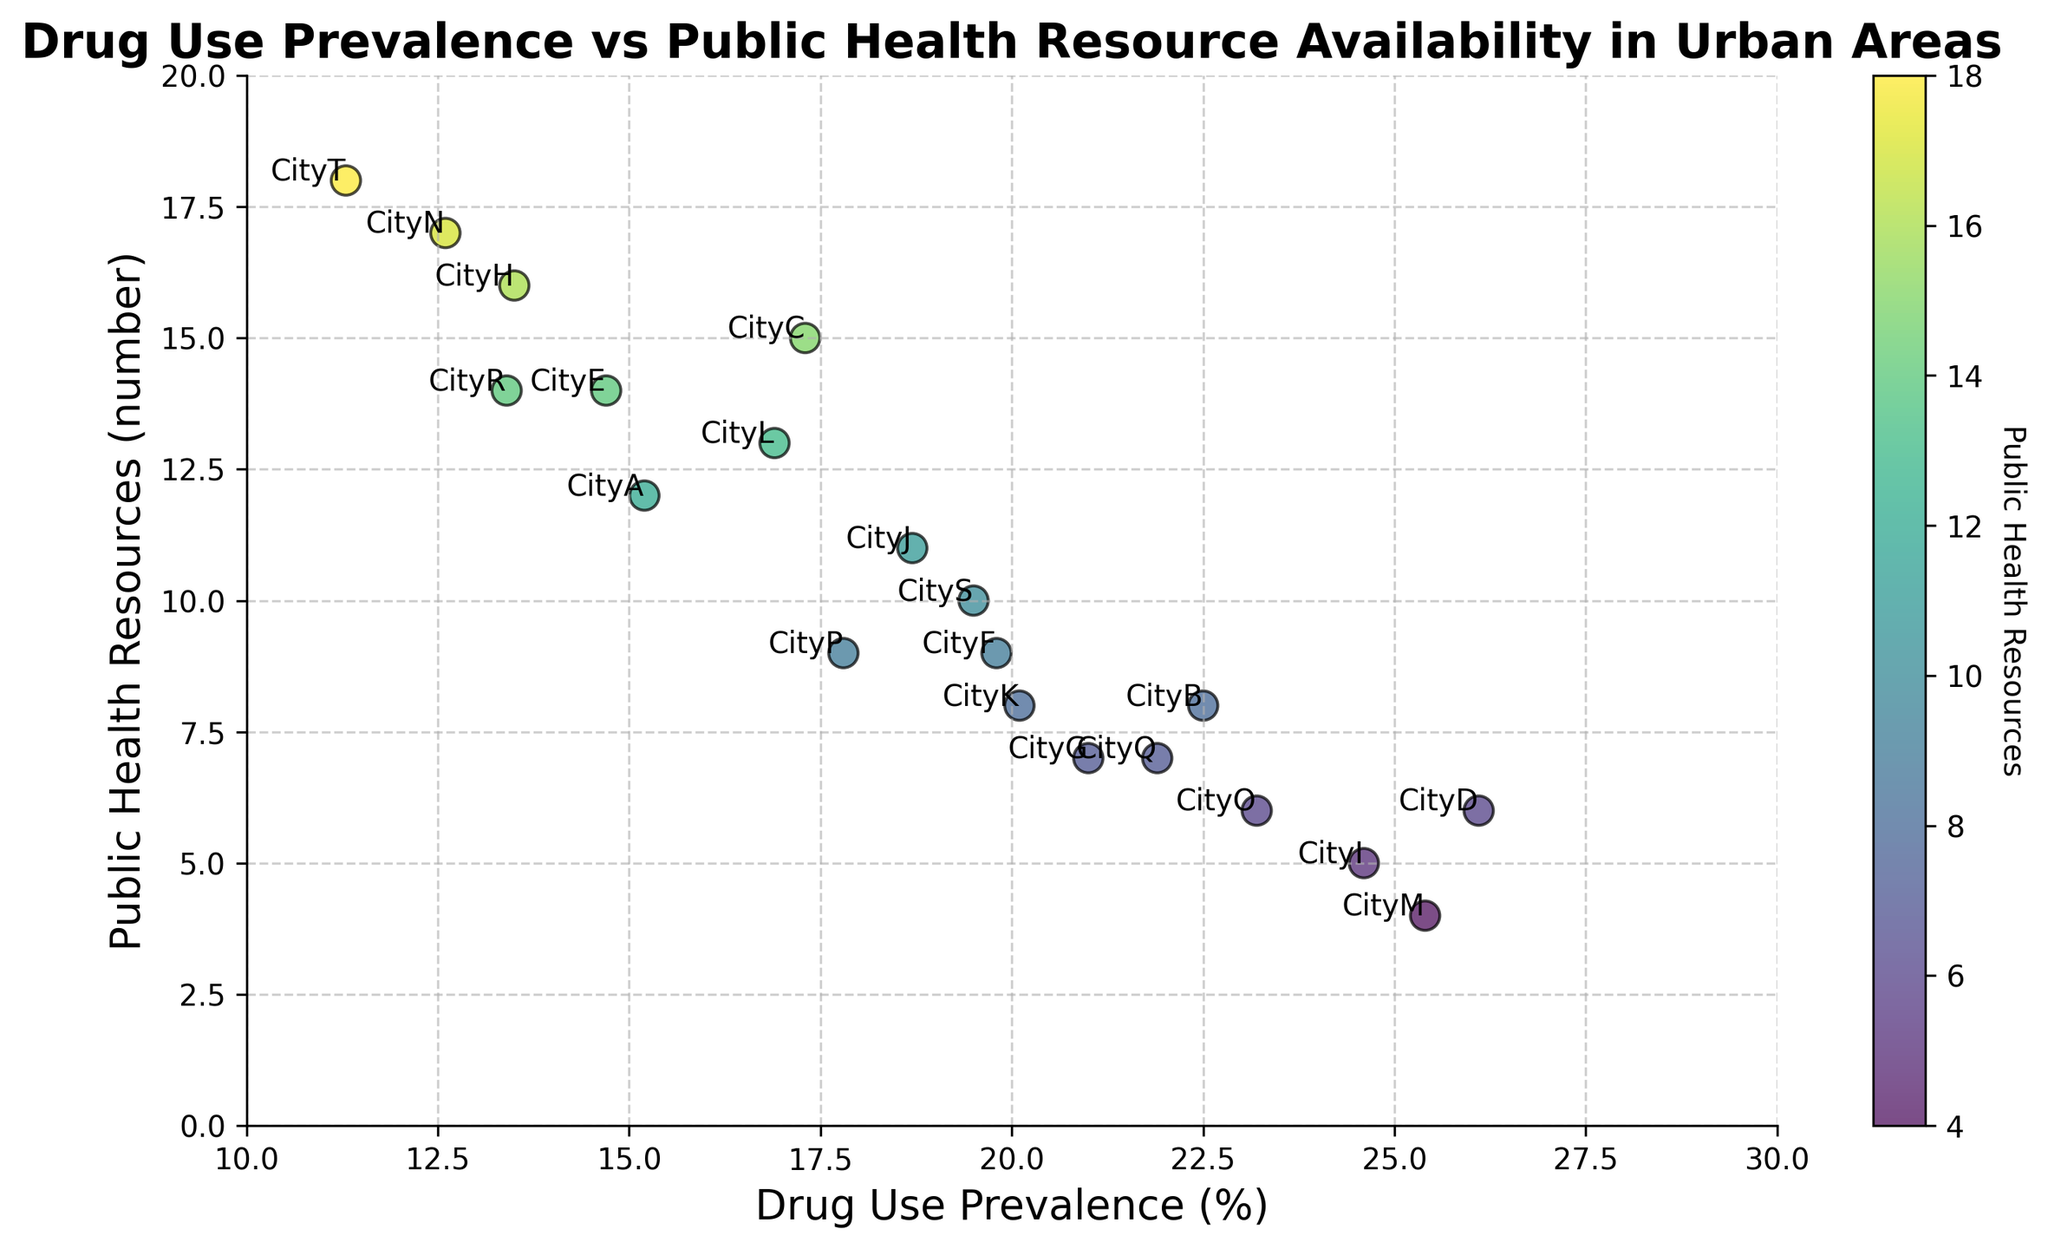Which city has the highest drug use prevalence? City D has the highest drug use prevalence at 26.1%, as observed at the peak point on the x-axis.
Answer: City D Which city has the lowest number of public health resources? City M has the lowest count of public health resources at 4, seen as the lowest point on the y-axis.
Answer: City M Is there a general trend between drug use prevalence and public health resources? Generally, cities with higher drug use prevalence tend to have fewer public health resources, as observed by the downward trend of points on the scatter plot.
Answer: Downward trend Which city balances drug use prevalence and public health resources most effectively? City N has relatively low drug use prevalence at 12.6% and high public health resources at 17, as depicted by its positioning in the lower right section of the plot.
Answer: City N What is the range of public health resources for cities with a drug use prevalence above 20%? For cities with drug use prevalence above 20%: City B (8 resources), City D (6 resources), City G (7 resources), City I (5 resources), City K (8 resources), City M (4 resources), City O (6 resources), and City Q (7 resources). The range is 4 to 8.
Answer: 4 to 8 Which two cities have similar drug use prevalence but differ significantly in public health resources? City Q and City K both have similar drug use prevalence (21.9% and 20.1%, respectively), but City K has 8 public health resources, while City Q has 7, showing a notable difference.
Answer: City K and City Q How does drug use prevalence in City T compare to City A? City T has a significantly lower drug use prevalence at 11.3%, while City A has a higher drug use prevalence at 15.2%.
Answer: City T < City A What is the median number of public health resources available for all cities? To find the median, list the number of resources in order: [4, 5, 6, 6, 7, 7, 8, 8, 9, 9, 10, 11, 12, 13, 14, 14, 15, 16, 17, 18]. 
   With 20 data points, the median is the average of the 10th and 11th values: (9 + 10) / 2 = 9.5.
Answer: 9.5 Does City E have more public health resources compared to City H? Yes, City E has 14 public health resources, while City H has 16, making City E have fewer resources compared to City H.
Answer: No Is there any city with both high drug use prevalence and high public health resources? No, none appears to have high drug use prevalence and a high number of public health resources; they typically exhibit inverse proportions.
Answer: No 